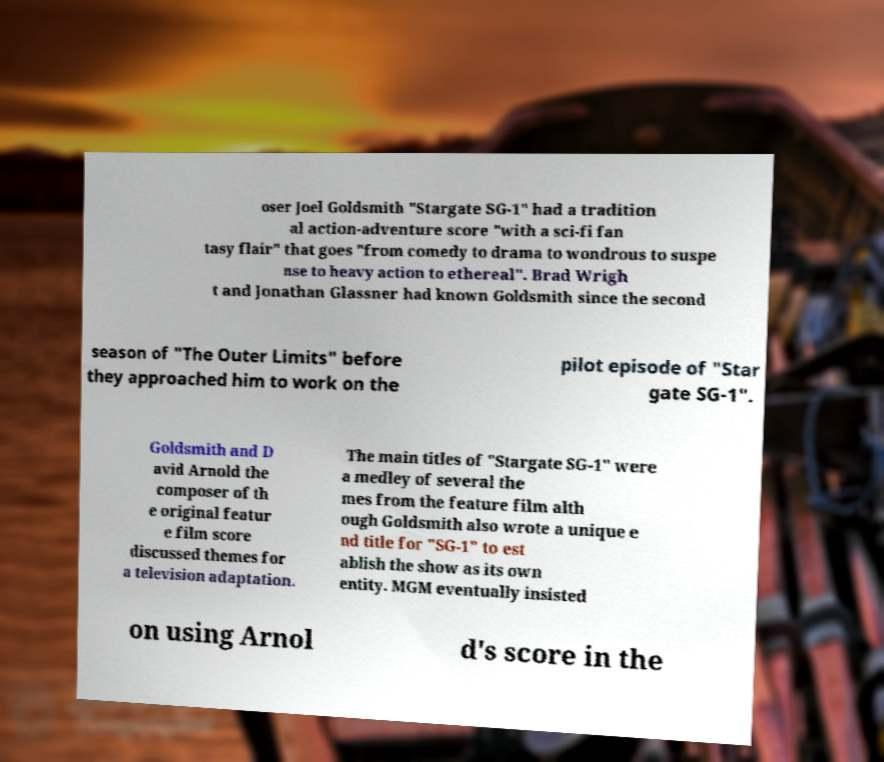What messages or text are displayed in this image? I need them in a readable, typed format. oser Joel Goldsmith "Stargate SG-1" had a tradition al action-adventure score "with a sci-fi fan tasy flair" that goes "from comedy to drama to wondrous to suspe nse to heavy action to ethereal". Brad Wrigh t and Jonathan Glassner had known Goldsmith since the second season of "The Outer Limits" before they approached him to work on the pilot episode of "Star gate SG-1". Goldsmith and D avid Arnold the composer of th e original featur e film score discussed themes for a television adaptation. The main titles of "Stargate SG-1" were a medley of several the mes from the feature film alth ough Goldsmith also wrote a unique e nd title for "SG-1" to est ablish the show as its own entity. MGM eventually insisted on using Arnol d's score in the 